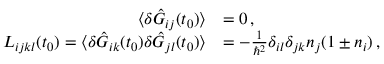<formula> <loc_0><loc_0><loc_500><loc_500>\begin{array} { r l } { \langle \delta \hat { G } _ { i j } ( t _ { 0 } ) \rangle } & { = 0 \, , } \\ { L _ { i j k l } ( t _ { 0 } ) = \langle \delta \hat { G } _ { i k } ( t _ { 0 } ) \delta \hat { G } _ { j l } ( t _ { 0 } ) \rangle } & { = - \frac { 1 } { \hbar { ^ } { 2 } } \delta _ { i l } \delta _ { j k } n _ { j } ( 1 \pm n _ { i } ) \, , \quad } \end{array}</formula> 